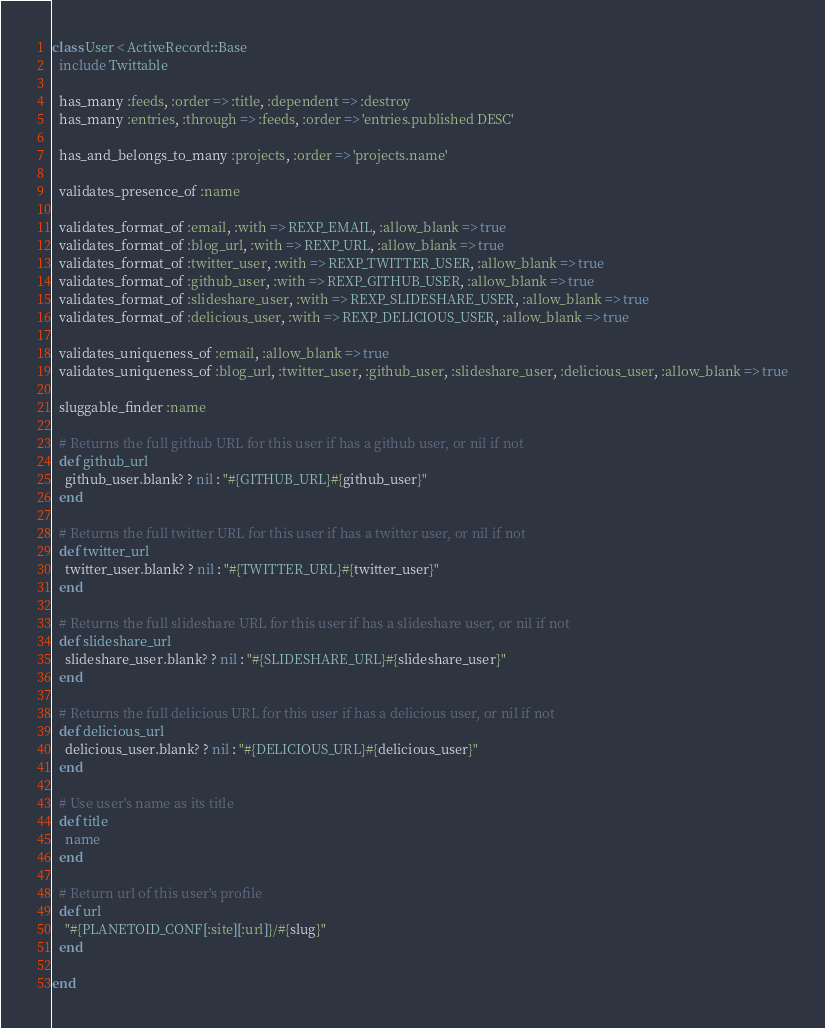Convert code to text. <code><loc_0><loc_0><loc_500><loc_500><_Ruby_>class User < ActiveRecord::Base
  include Twittable
  
  has_many :feeds, :order => :title, :dependent => :destroy
  has_many :entries, :through => :feeds, :order => 'entries.published DESC'
  
  has_and_belongs_to_many :projects, :order => 'projects.name'
  
  validates_presence_of :name

  validates_format_of :email, :with => REXP_EMAIL, :allow_blank => true
  validates_format_of :blog_url, :with => REXP_URL, :allow_blank => true
  validates_format_of :twitter_user, :with => REXP_TWITTER_USER, :allow_blank => true
  validates_format_of :github_user, :with => REXP_GITHUB_USER, :allow_blank => true
  validates_format_of :slideshare_user, :with => REXP_SLIDESHARE_USER, :allow_blank => true  
  validates_format_of :delicious_user, :with => REXP_DELICIOUS_USER, :allow_blank => true  
    
  validates_uniqueness_of :email, :allow_blank => true
  validates_uniqueness_of :blog_url, :twitter_user, :github_user, :slideshare_user, :delicious_user, :allow_blank => true
  
  sluggable_finder :name
    
  # Returns the full github URL for this user if has a github user, or nil if not
  def github_url
    github_user.blank? ? nil : "#{GITHUB_URL}#{github_user}"
  end
  
  # Returns the full twitter URL for this user if has a twitter user, or nil if not
  def twitter_url
    twitter_user.blank? ? nil : "#{TWITTER_URL}#{twitter_user}"
  end
  
  # Returns the full slideshare URL for this user if has a slideshare user, or nil if not
  def slideshare_url
    slideshare_user.blank? ? nil : "#{SLIDESHARE_URL}#{slideshare_user}"
  end
  
  # Returns the full delicious URL for this user if has a delicious user, or nil if not
  def delicious_url
    delicious_user.blank? ? nil : "#{DELICIOUS_URL}#{delicious_user}"
  end
  
  # Use user's name as its title
  def title
    name
  end
  
  # Return url of this user's profile
  def url
    "#{PLANETOID_CONF[:site][:url]}/#{slug}"
  end

end
</code> 